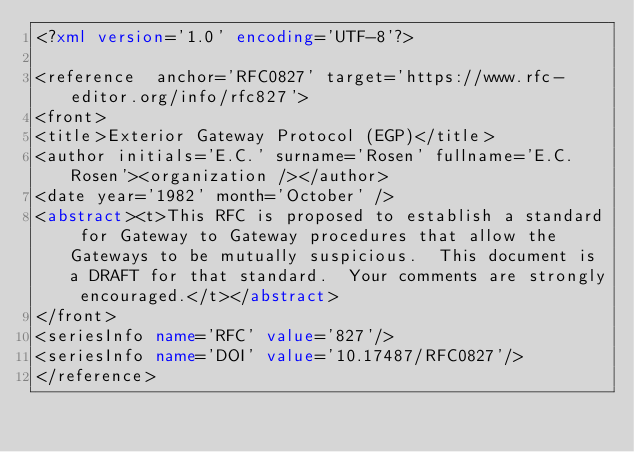<code> <loc_0><loc_0><loc_500><loc_500><_XML_><?xml version='1.0' encoding='UTF-8'?>

<reference  anchor='RFC0827' target='https://www.rfc-editor.org/info/rfc827'>
<front>
<title>Exterior Gateway Protocol (EGP)</title>
<author initials='E.C.' surname='Rosen' fullname='E.C. Rosen'><organization /></author>
<date year='1982' month='October' />
<abstract><t>This RFC is proposed to establish a standard for Gateway to Gateway procedures that allow the Gateways to be mutually suspicious.  This document is a DRAFT for that standard.  Your comments are strongly encouraged.</t></abstract>
</front>
<seriesInfo name='RFC' value='827'/>
<seriesInfo name='DOI' value='10.17487/RFC0827'/>
</reference>
</code> 